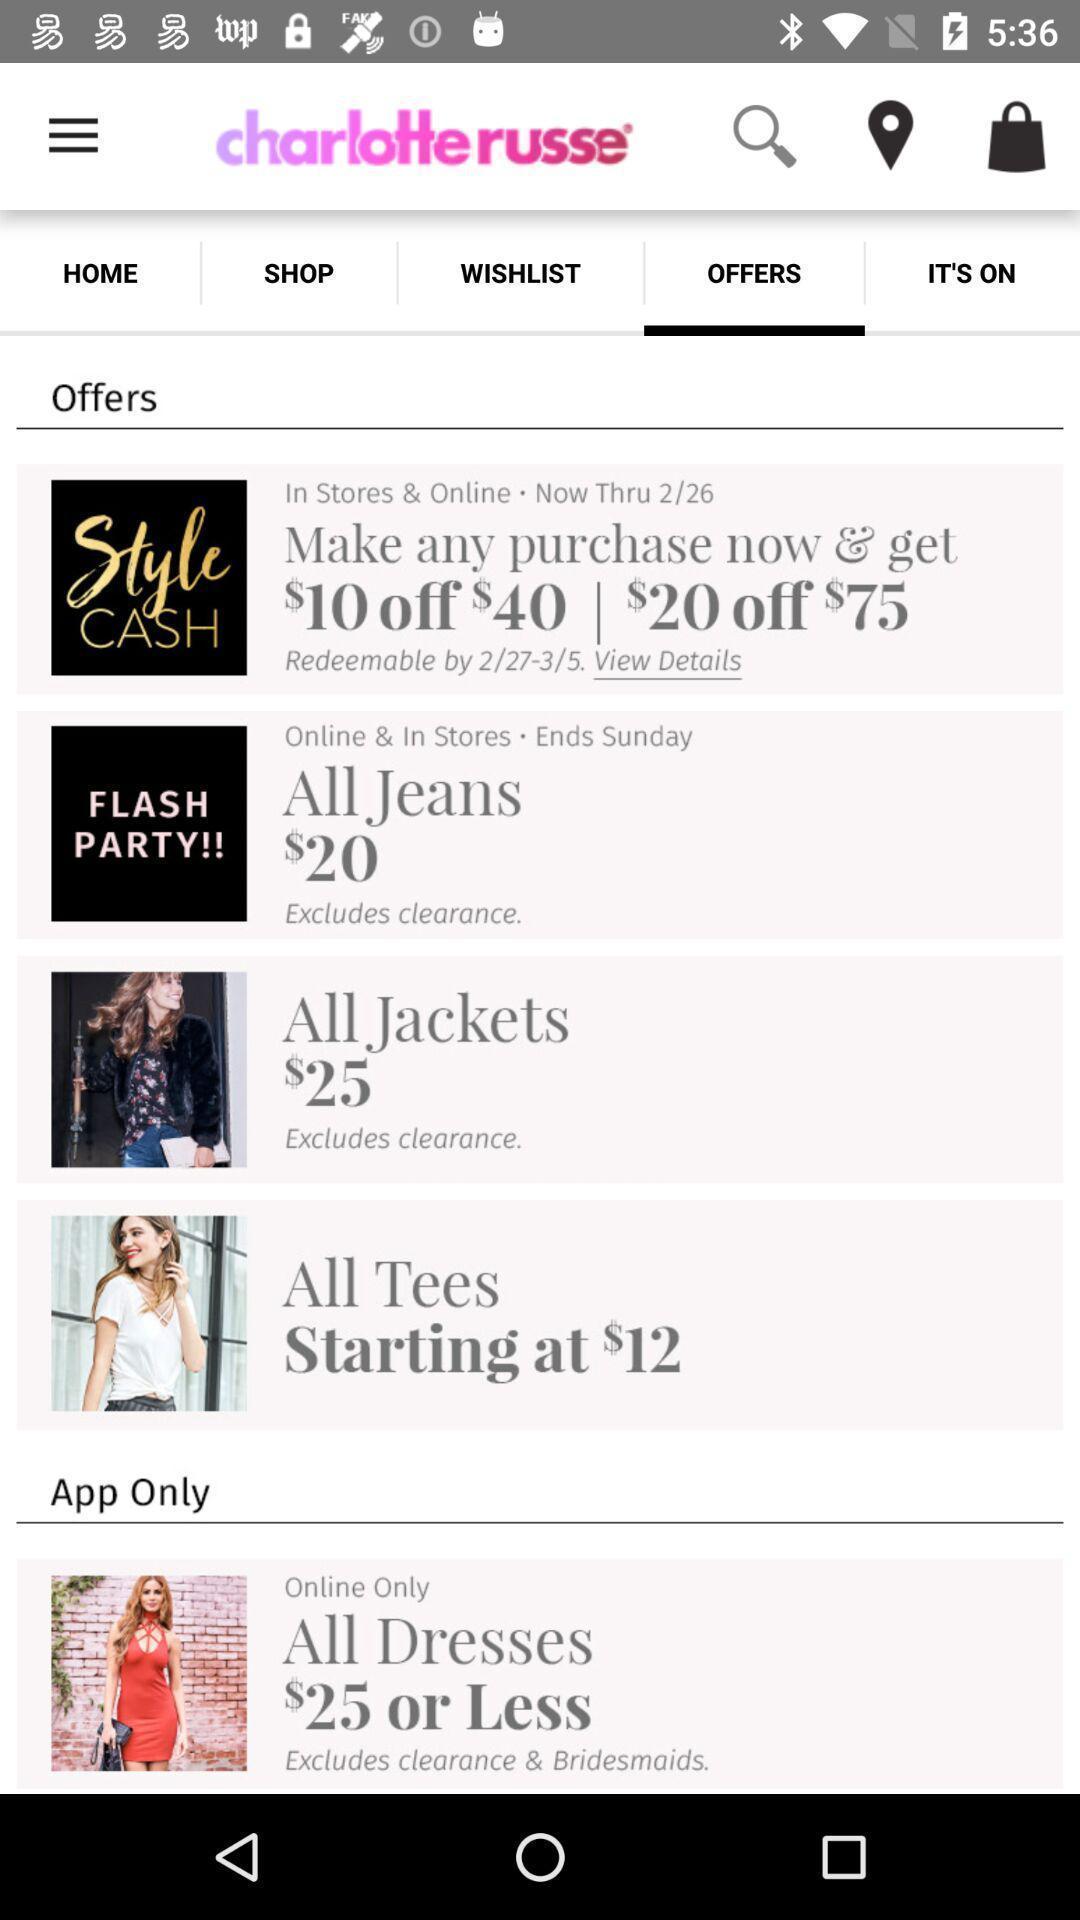Describe the content in this image. Shopping app displayed offers page and other options. 